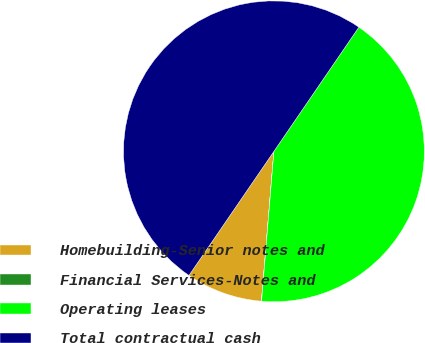Convert chart. <chart><loc_0><loc_0><loc_500><loc_500><pie_chart><fcel>Homebuilding-Senior notes and<fcel>Financial Services-Notes and<fcel>Operating leases<fcel>Total contractual cash<nl><fcel>8.23%<fcel>0.02%<fcel>41.76%<fcel>50.0%<nl></chart> 